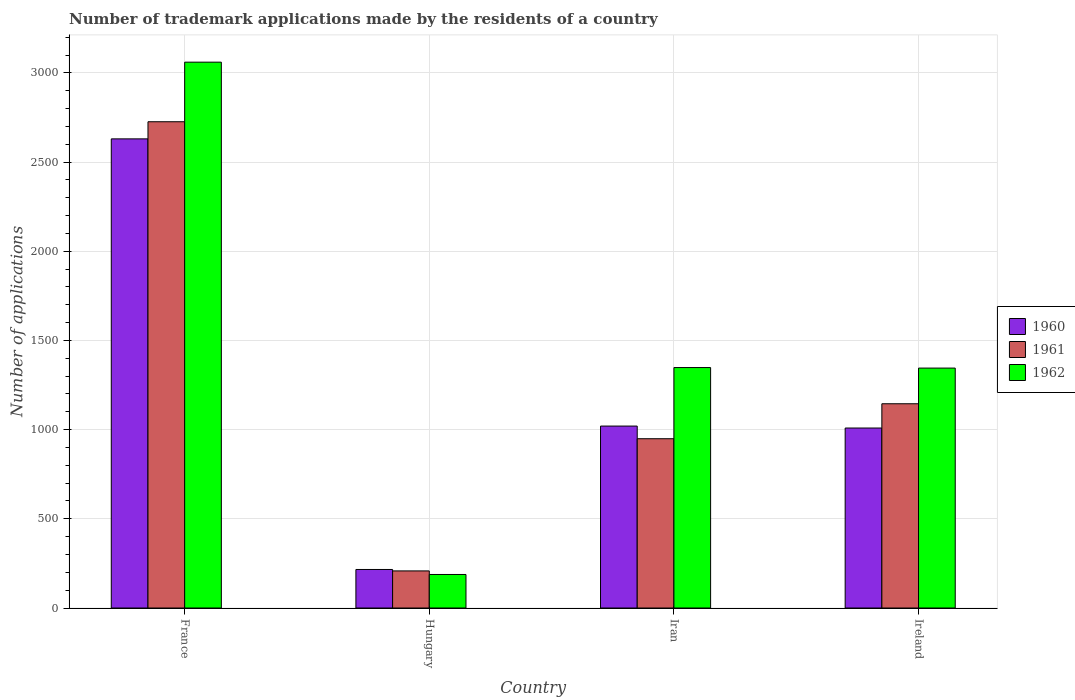How many bars are there on the 4th tick from the left?
Your answer should be compact. 3. What is the label of the 3rd group of bars from the left?
Ensure brevity in your answer.  Iran. In how many cases, is the number of bars for a given country not equal to the number of legend labels?
Your answer should be compact. 0. What is the number of trademark applications made by the residents in 1962 in Hungary?
Offer a very short reply. 188. Across all countries, what is the maximum number of trademark applications made by the residents in 1960?
Give a very brief answer. 2630. Across all countries, what is the minimum number of trademark applications made by the residents in 1960?
Ensure brevity in your answer.  216. In which country was the number of trademark applications made by the residents in 1961 minimum?
Offer a very short reply. Hungary. What is the total number of trademark applications made by the residents in 1962 in the graph?
Provide a succinct answer. 5941. What is the difference between the number of trademark applications made by the residents in 1962 in Hungary and that in Ireland?
Your answer should be compact. -1157. What is the difference between the number of trademark applications made by the residents in 1962 in Iran and the number of trademark applications made by the residents in 1961 in Hungary?
Your answer should be compact. 1140. What is the average number of trademark applications made by the residents in 1962 per country?
Make the answer very short. 1485.25. What is the difference between the number of trademark applications made by the residents of/in 1962 and number of trademark applications made by the residents of/in 1960 in France?
Provide a short and direct response. 430. In how many countries, is the number of trademark applications made by the residents in 1961 greater than 1800?
Give a very brief answer. 1. What is the ratio of the number of trademark applications made by the residents in 1960 in Hungary to that in Iran?
Offer a terse response. 0.21. What is the difference between the highest and the lowest number of trademark applications made by the residents in 1960?
Provide a succinct answer. 2414. In how many countries, is the number of trademark applications made by the residents in 1961 greater than the average number of trademark applications made by the residents in 1961 taken over all countries?
Your response must be concise. 1. Is the sum of the number of trademark applications made by the residents in 1961 in France and Hungary greater than the maximum number of trademark applications made by the residents in 1962 across all countries?
Give a very brief answer. No. Is it the case that in every country, the sum of the number of trademark applications made by the residents in 1961 and number of trademark applications made by the residents in 1960 is greater than the number of trademark applications made by the residents in 1962?
Provide a succinct answer. Yes. How many bars are there?
Provide a succinct answer. 12. Are all the bars in the graph horizontal?
Offer a terse response. No. How many countries are there in the graph?
Provide a short and direct response. 4. Does the graph contain any zero values?
Give a very brief answer. No. Does the graph contain grids?
Ensure brevity in your answer.  Yes. How are the legend labels stacked?
Offer a very short reply. Vertical. What is the title of the graph?
Provide a short and direct response. Number of trademark applications made by the residents of a country. Does "1969" appear as one of the legend labels in the graph?
Offer a very short reply. No. What is the label or title of the Y-axis?
Ensure brevity in your answer.  Number of applications. What is the Number of applications of 1960 in France?
Provide a succinct answer. 2630. What is the Number of applications in 1961 in France?
Your answer should be very brief. 2726. What is the Number of applications of 1962 in France?
Offer a terse response. 3060. What is the Number of applications of 1960 in Hungary?
Keep it short and to the point. 216. What is the Number of applications of 1961 in Hungary?
Provide a succinct answer. 208. What is the Number of applications of 1962 in Hungary?
Offer a terse response. 188. What is the Number of applications of 1960 in Iran?
Give a very brief answer. 1020. What is the Number of applications in 1961 in Iran?
Provide a succinct answer. 949. What is the Number of applications in 1962 in Iran?
Give a very brief answer. 1348. What is the Number of applications in 1960 in Ireland?
Ensure brevity in your answer.  1009. What is the Number of applications of 1961 in Ireland?
Make the answer very short. 1145. What is the Number of applications in 1962 in Ireland?
Give a very brief answer. 1345. Across all countries, what is the maximum Number of applications of 1960?
Keep it short and to the point. 2630. Across all countries, what is the maximum Number of applications of 1961?
Make the answer very short. 2726. Across all countries, what is the maximum Number of applications in 1962?
Give a very brief answer. 3060. Across all countries, what is the minimum Number of applications of 1960?
Keep it short and to the point. 216. Across all countries, what is the minimum Number of applications of 1961?
Provide a short and direct response. 208. Across all countries, what is the minimum Number of applications in 1962?
Keep it short and to the point. 188. What is the total Number of applications in 1960 in the graph?
Make the answer very short. 4875. What is the total Number of applications of 1961 in the graph?
Your response must be concise. 5028. What is the total Number of applications of 1962 in the graph?
Offer a very short reply. 5941. What is the difference between the Number of applications in 1960 in France and that in Hungary?
Offer a terse response. 2414. What is the difference between the Number of applications in 1961 in France and that in Hungary?
Keep it short and to the point. 2518. What is the difference between the Number of applications in 1962 in France and that in Hungary?
Keep it short and to the point. 2872. What is the difference between the Number of applications in 1960 in France and that in Iran?
Keep it short and to the point. 1610. What is the difference between the Number of applications of 1961 in France and that in Iran?
Offer a very short reply. 1777. What is the difference between the Number of applications of 1962 in France and that in Iran?
Your answer should be compact. 1712. What is the difference between the Number of applications of 1960 in France and that in Ireland?
Your answer should be very brief. 1621. What is the difference between the Number of applications in 1961 in France and that in Ireland?
Your response must be concise. 1581. What is the difference between the Number of applications of 1962 in France and that in Ireland?
Your answer should be compact. 1715. What is the difference between the Number of applications in 1960 in Hungary and that in Iran?
Ensure brevity in your answer.  -804. What is the difference between the Number of applications in 1961 in Hungary and that in Iran?
Your answer should be very brief. -741. What is the difference between the Number of applications of 1962 in Hungary and that in Iran?
Your response must be concise. -1160. What is the difference between the Number of applications of 1960 in Hungary and that in Ireland?
Your answer should be very brief. -793. What is the difference between the Number of applications in 1961 in Hungary and that in Ireland?
Your answer should be compact. -937. What is the difference between the Number of applications of 1962 in Hungary and that in Ireland?
Make the answer very short. -1157. What is the difference between the Number of applications in 1961 in Iran and that in Ireland?
Your answer should be compact. -196. What is the difference between the Number of applications of 1962 in Iran and that in Ireland?
Keep it short and to the point. 3. What is the difference between the Number of applications in 1960 in France and the Number of applications in 1961 in Hungary?
Your answer should be compact. 2422. What is the difference between the Number of applications in 1960 in France and the Number of applications in 1962 in Hungary?
Your response must be concise. 2442. What is the difference between the Number of applications in 1961 in France and the Number of applications in 1962 in Hungary?
Your response must be concise. 2538. What is the difference between the Number of applications in 1960 in France and the Number of applications in 1961 in Iran?
Give a very brief answer. 1681. What is the difference between the Number of applications in 1960 in France and the Number of applications in 1962 in Iran?
Your answer should be very brief. 1282. What is the difference between the Number of applications in 1961 in France and the Number of applications in 1962 in Iran?
Your response must be concise. 1378. What is the difference between the Number of applications in 1960 in France and the Number of applications in 1961 in Ireland?
Your response must be concise. 1485. What is the difference between the Number of applications of 1960 in France and the Number of applications of 1962 in Ireland?
Make the answer very short. 1285. What is the difference between the Number of applications in 1961 in France and the Number of applications in 1962 in Ireland?
Give a very brief answer. 1381. What is the difference between the Number of applications in 1960 in Hungary and the Number of applications in 1961 in Iran?
Provide a succinct answer. -733. What is the difference between the Number of applications in 1960 in Hungary and the Number of applications in 1962 in Iran?
Provide a short and direct response. -1132. What is the difference between the Number of applications in 1961 in Hungary and the Number of applications in 1962 in Iran?
Offer a very short reply. -1140. What is the difference between the Number of applications of 1960 in Hungary and the Number of applications of 1961 in Ireland?
Ensure brevity in your answer.  -929. What is the difference between the Number of applications in 1960 in Hungary and the Number of applications in 1962 in Ireland?
Offer a terse response. -1129. What is the difference between the Number of applications of 1961 in Hungary and the Number of applications of 1962 in Ireland?
Your answer should be very brief. -1137. What is the difference between the Number of applications in 1960 in Iran and the Number of applications in 1961 in Ireland?
Your response must be concise. -125. What is the difference between the Number of applications of 1960 in Iran and the Number of applications of 1962 in Ireland?
Your answer should be very brief. -325. What is the difference between the Number of applications of 1961 in Iran and the Number of applications of 1962 in Ireland?
Provide a short and direct response. -396. What is the average Number of applications in 1960 per country?
Your answer should be very brief. 1218.75. What is the average Number of applications of 1961 per country?
Keep it short and to the point. 1257. What is the average Number of applications of 1962 per country?
Your answer should be compact. 1485.25. What is the difference between the Number of applications in 1960 and Number of applications in 1961 in France?
Provide a short and direct response. -96. What is the difference between the Number of applications in 1960 and Number of applications in 1962 in France?
Your answer should be very brief. -430. What is the difference between the Number of applications of 1961 and Number of applications of 1962 in France?
Offer a very short reply. -334. What is the difference between the Number of applications in 1960 and Number of applications in 1961 in Hungary?
Ensure brevity in your answer.  8. What is the difference between the Number of applications of 1960 and Number of applications of 1962 in Iran?
Give a very brief answer. -328. What is the difference between the Number of applications of 1961 and Number of applications of 1962 in Iran?
Your response must be concise. -399. What is the difference between the Number of applications of 1960 and Number of applications of 1961 in Ireland?
Keep it short and to the point. -136. What is the difference between the Number of applications in 1960 and Number of applications in 1962 in Ireland?
Your answer should be compact. -336. What is the difference between the Number of applications of 1961 and Number of applications of 1962 in Ireland?
Your answer should be very brief. -200. What is the ratio of the Number of applications of 1960 in France to that in Hungary?
Your answer should be compact. 12.18. What is the ratio of the Number of applications in 1961 in France to that in Hungary?
Your answer should be very brief. 13.11. What is the ratio of the Number of applications in 1962 in France to that in Hungary?
Keep it short and to the point. 16.28. What is the ratio of the Number of applications in 1960 in France to that in Iran?
Provide a short and direct response. 2.58. What is the ratio of the Number of applications of 1961 in France to that in Iran?
Keep it short and to the point. 2.87. What is the ratio of the Number of applications in 1962 in France to that in Iran?
Your answer should be compact. 2.27. What is the ratio of the Number of applications of 1960 in France to that in Ireland?
Your response must be concise. 2.61. What is the ratio of the Number of applications in 1961 in France to that in Ireland?
Your response must be concise. 2.38. What is the ratio of the Number of applications in 1962 in France to that in Ireland?
Your answer should be very brief. 2.28. What is the ratio of the Number of applications of 1960 in Hungary to that in Iran?
Keep it short and to the point. 0.21. What is the ratio of the Number of applications of 1961 in Hungary to that in Iran?
Keep it short and to the point. 0.22. What is the ratio of the Number of applications in 1962 in Hungary to that in Iran?
Your answer should be very brief. 0.14. What is the ratio of the Number of applications in 1960 in Hungary to that in Ireland?
Your response must be concise. 0.21. What is the ratio of the Number of applications of 1961 in Hungary to that in Ireland?
Your response must be concise. 0.18. What is the ratio of the Number of applications in 1962 in Hungary to that in Ireland?
Keep it short and to the point. 0.14. What is the ratio of the Number of applications of 1960 in Iran to that in Ireland?
Offer a terse response. 1.01. What is the ratio of the Number of applications in 1961 in Iran to that in Ireland?
Your answer should be very brief. 0.83. What is the ratio of the Number of applications of 1962 in Iran to that in Ireland?
Provide a succinct answer. 1. What is the difference between the highest and the second highest Number of applications of 1960?
Your response must be concise. 1610. What is the difference between the highest and the second highest Number of applications of 1961?
Ensure brevity in your answer.  1581. What is the difference between the highest and the second highest Number of applications in 1962?
Offer a terse response. 1712. What is the difference between the highest and the lowest Number of applications of 1960?
Provide a succinct answer. 2414. What is the difference between the highest and the lowest Number of applications of 1961?
Make the answer very short. 2518. What is the difference between the highest and the lowest Number of applications in 1962?
Ensure brevity in your answer.  2872. 